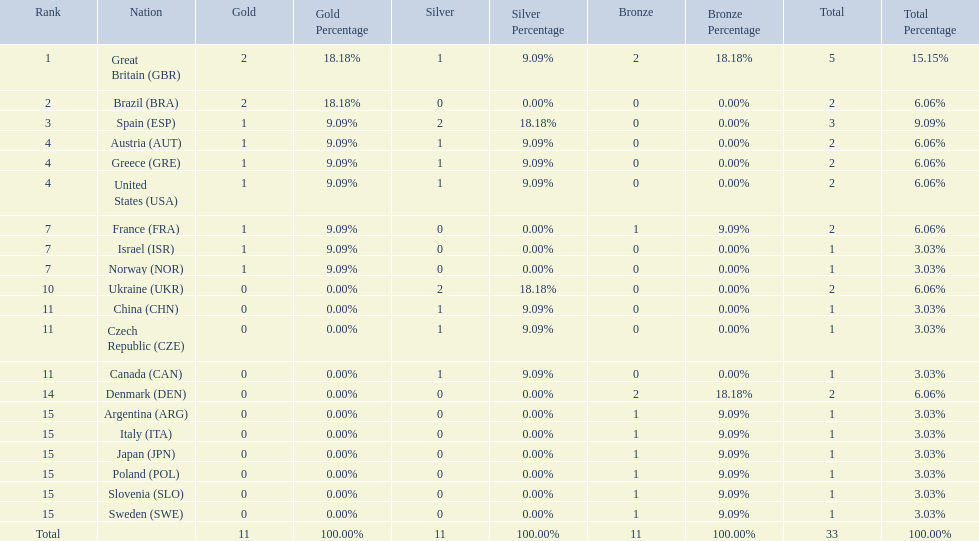Which nation received 2 silver medals? Spain (ESP), Ukraine (UKR). Of those, which nation also had 2 total medals? Spain (ESP). 